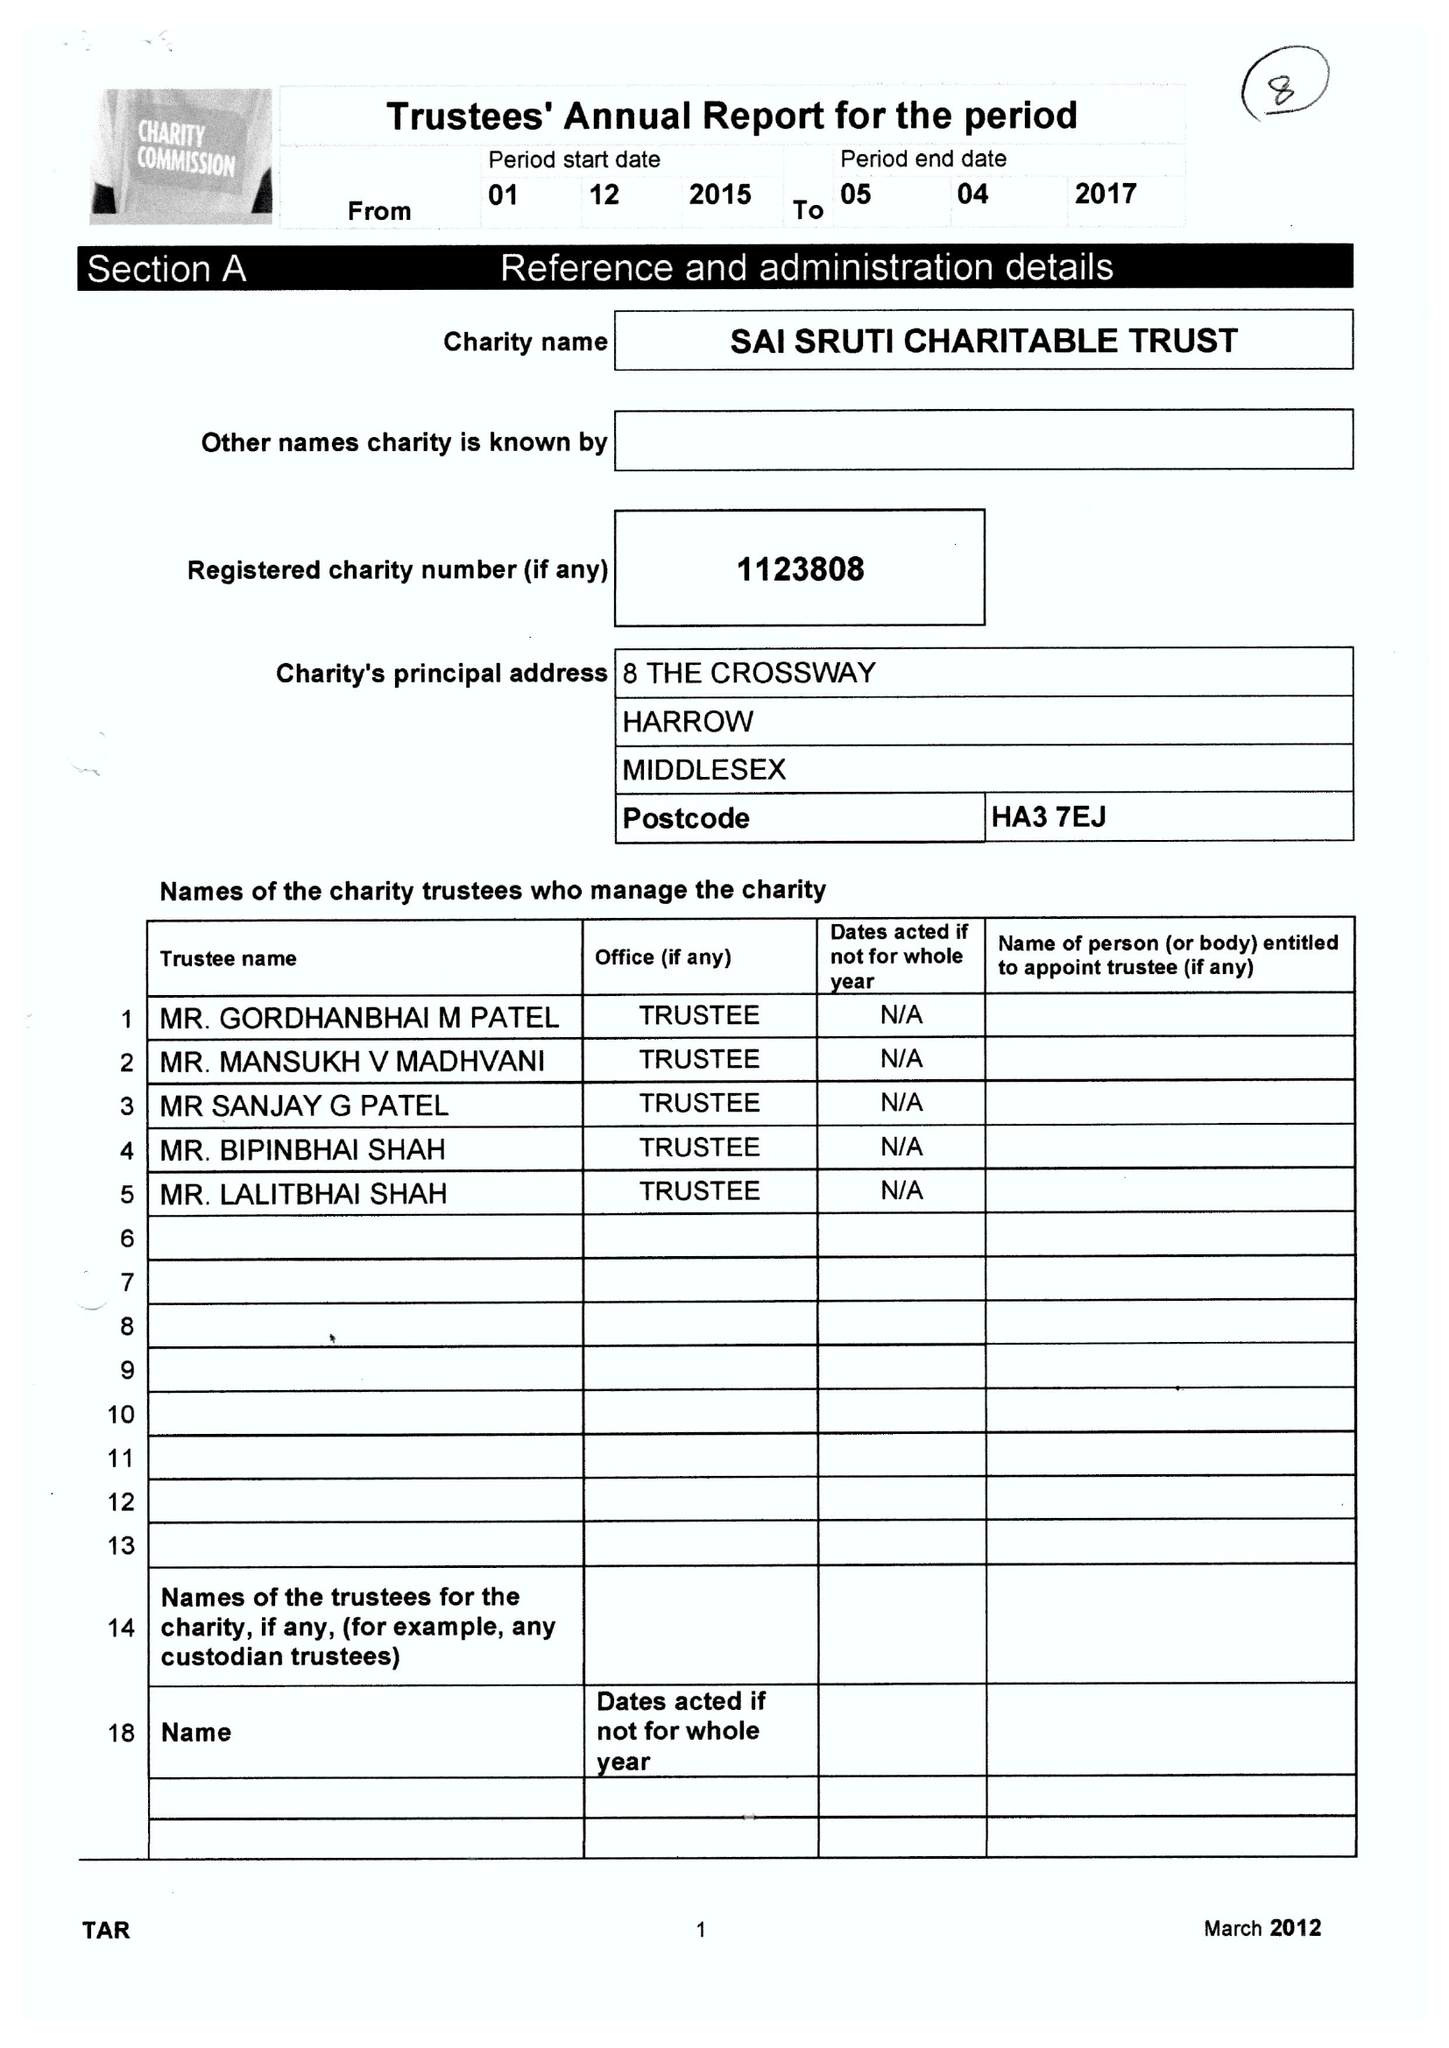What is the value for the address__post_town?
Answer the question using a single word or phrase. HARROW 